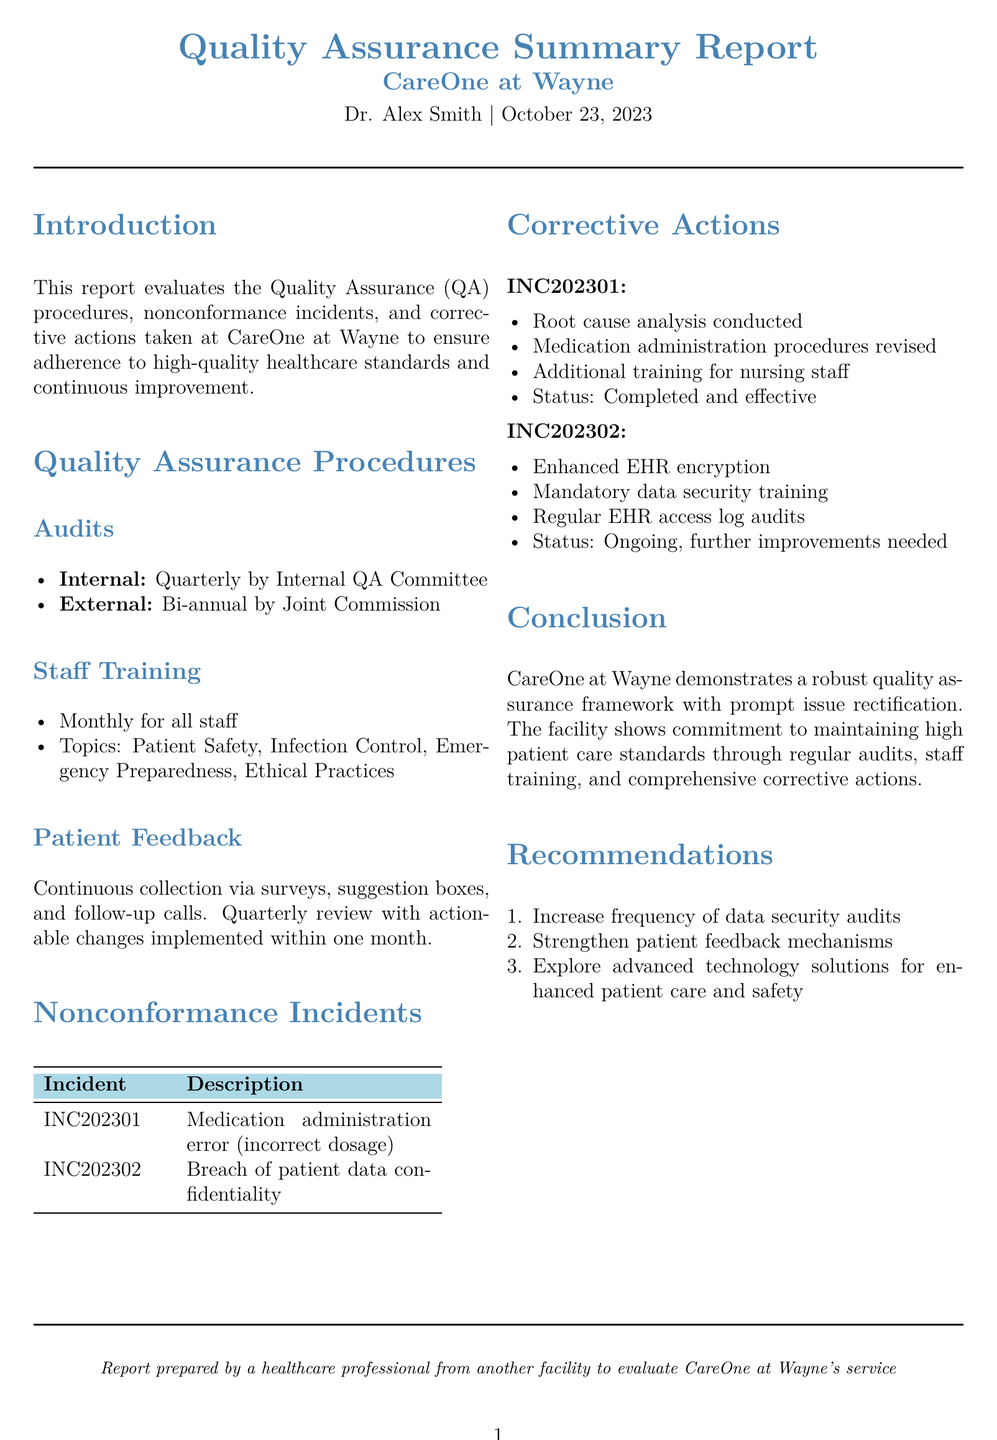What is the name of the prepared report? The report title is a statement of its content, indicating it's a quality assurance summary report.
Answer: Quality Assurance Summary Report Who conducted the internal audits? The internal audits are conducted by a specific committee tasked with quality assurance oversight within the facility.
Answer: Internal QA Committee How often are staff training sessions conducted? Staff training sessions are conducted on a monthly basis for all staff members.
Answer: Monthly What was one of the nonconformance incidents reported? The document lists specific nonconformance incidents related to patient care and data management.
Answer: Medication administration error (incorrect dosage) What corrective action was taken for the data confidentiality breach? The actions taken involve enhancing specific technology measures and providing mandatory training to prevent future occurrences.
Answer: Enhanced EHR encryption How often does the Joint Commission conduct external audits? The frequency of external audits serves as a measure of the facility's compliance with broader healthcare standards.
Answer: Bi-annual What is the status of the corrective actions for the medication error incident? The provided status indicates the completion and effectiveness of the actions taken to address the incident.
Answer: Completed and effective Which area of training is emphasized in the staff training sessions? The training topics are designed to cover important aspects of patient safety and ethical practices necessary in healthcare settings.
Answer: Patient Safety What is a recommendation made in the report? Recommendations are provided to enhance specific aspects of facility operations and patient care based on the evaluations conducted.
Answer: Increase frequency of data security audits 